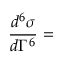<formula> <loc_0><loc_0><loc_500><loc_500>{ \frac { d ^ { 6 } \sigma } { d \Gamma ^ { 6 } } } =</formula> 